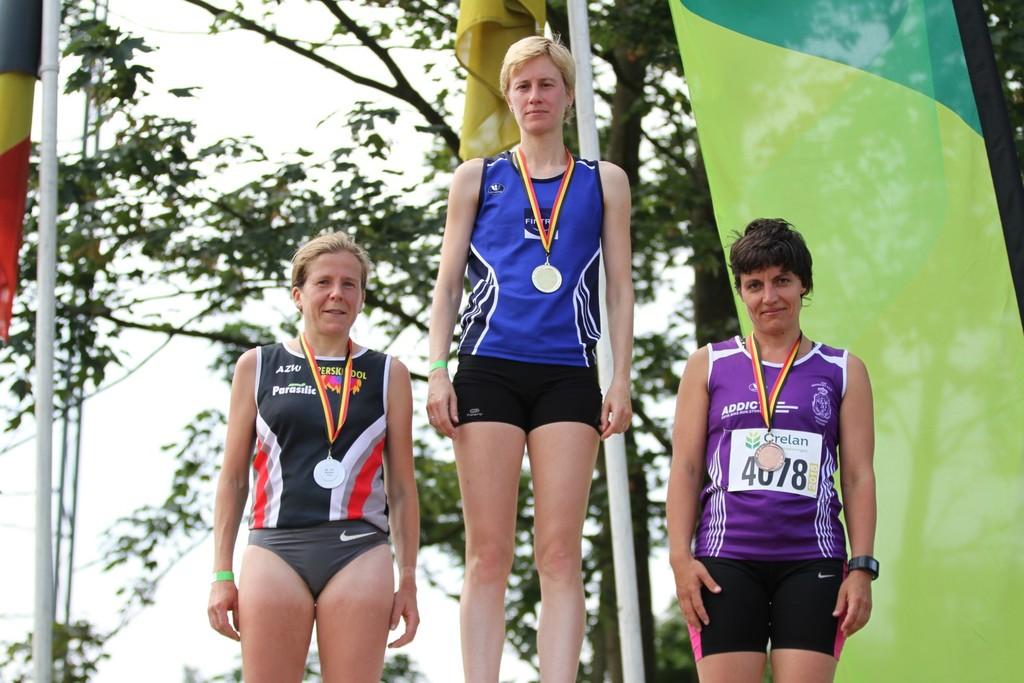What is one of the sponsors listed on the second place winner's shirt?
Ensure brevity in your answer.  Parasilic. 